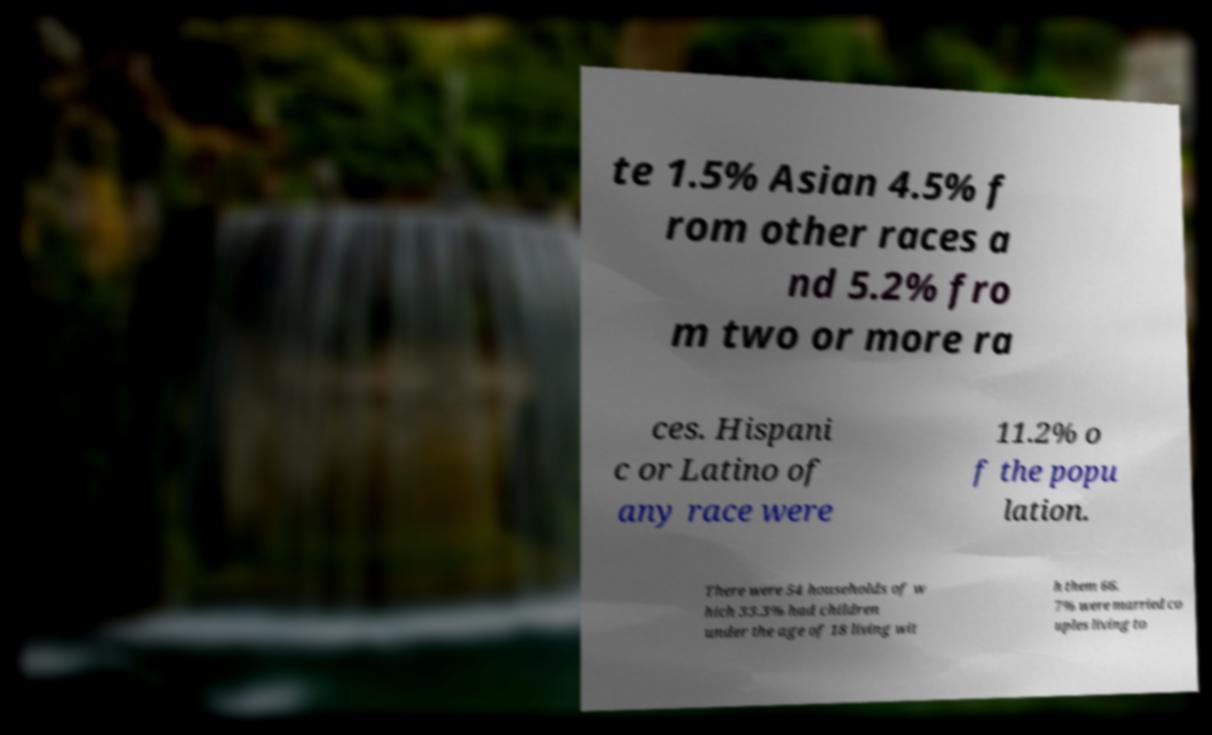Could you extract and type out the text from this image? te 1.5% Asian 4.5% f rom other races a nd 5.2% fro m two or more ra ces. Hispani c or Latino of any race were 11.2% o f the popu lation. There were 54 households of w hich 33.3% had children under the age of 18 living wit h them 66. 7% were married co uples living to 